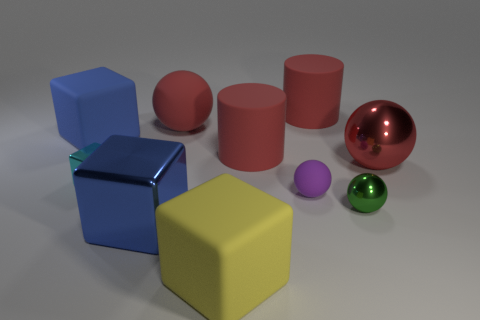Which objects in the image have a cylindrical shape? The three pink objects in the image are cylinders. They have a circular base and maintain the same diameter from bottom to top. 